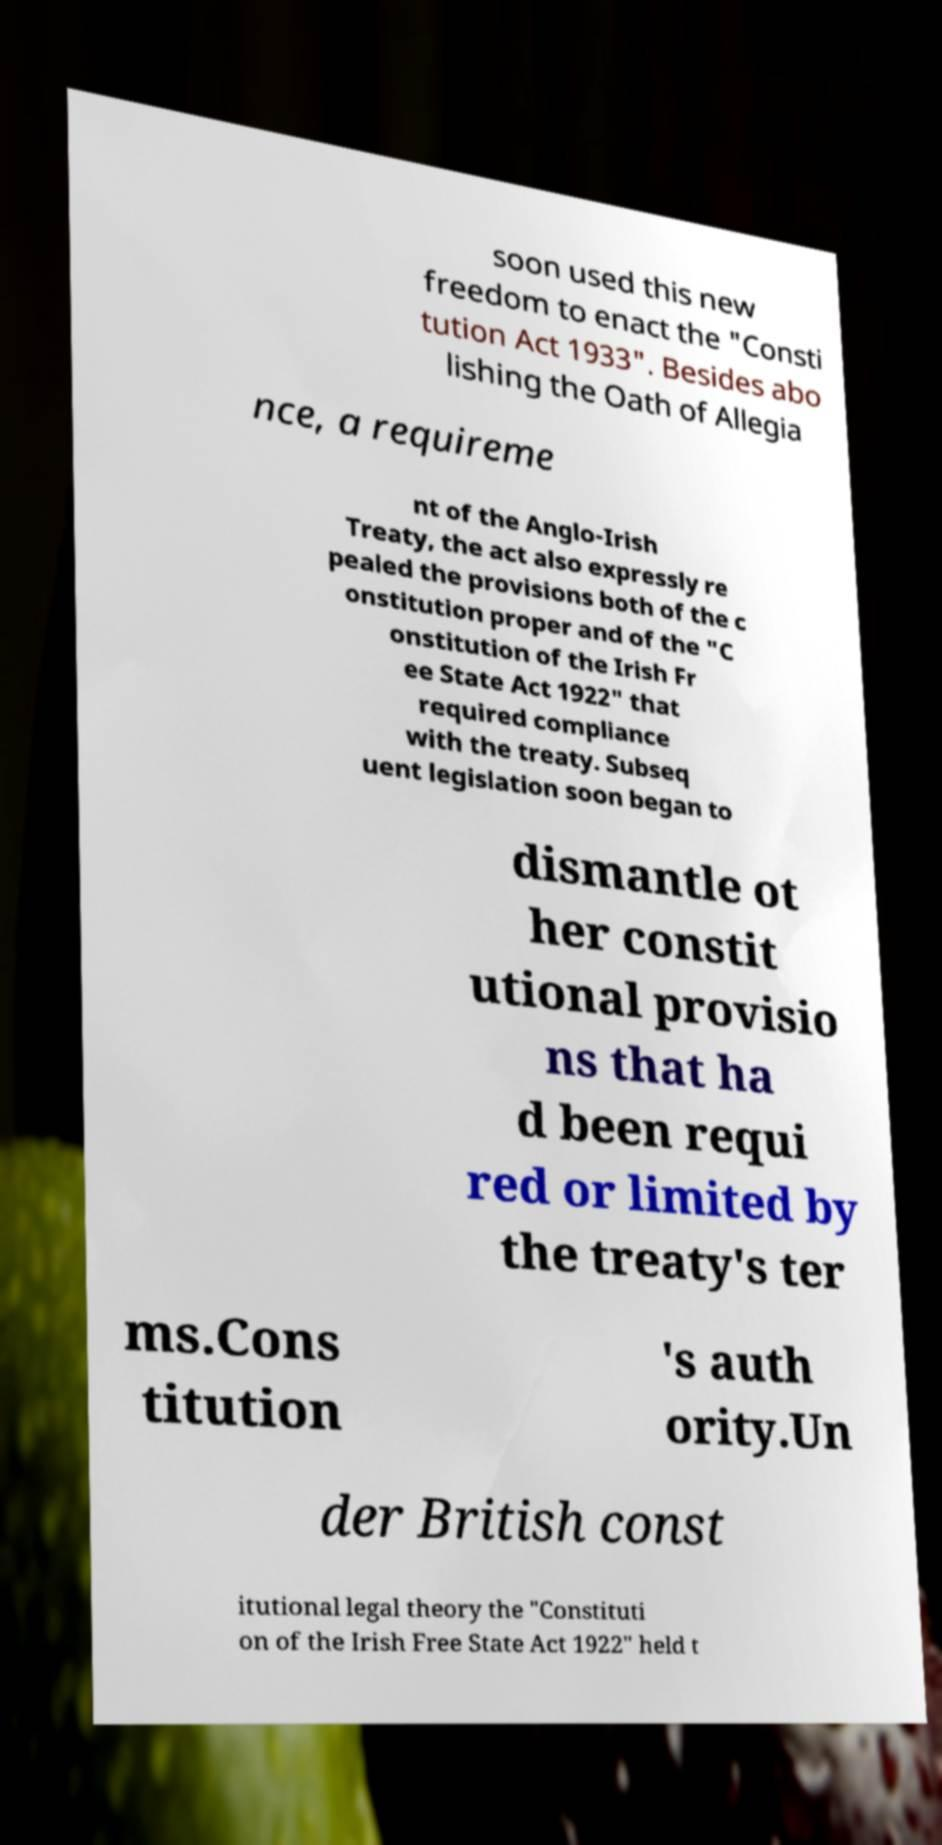Please identify and transcribe the text found in this image. soon used this new freedom to enact the "Consti tution Act 1933". Besides abo lishing the Oath of Allegia nce, a requireme nt of the Anglo-Irish Treaty, the act also expressly re pealed the provisions both of the c onstitution proper and of the "C onstitution of the Irish Fr ee State Act 1922" that required compliance with the treaty. Subseq uent legislation soon began to dismantle ot her constit utional provisio ns that ha d been requi red or limited by the treaty's ter ms.Cons titution 's auth ority.Un der British const itutional legal theory the "Constituti on of the Irish Free State Act 1922" held t 